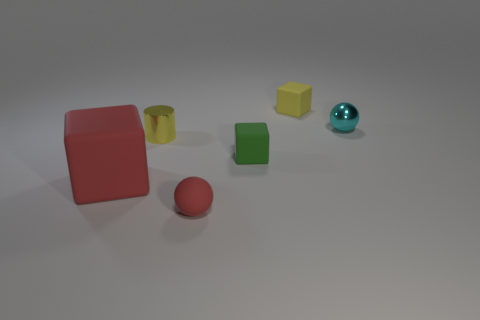What number of other things are the same color as the tiny shiny cylinder?
Provide a succinct answer. 1. How many small metallic objects are on the right side of the rubber thing behind the shiny object in front of the small cyan object?
Provide a short and direct response. 1. The cube that is in front of the small yellow metal object and behind the big cube is made of what material?
Keep it short and to the point. Rubber. Is the tiny red sphere made of the same material as the ball that is behind the big red cube?
Provide a short and direct response. No. Are there more large blocks behind the metallic cylinder than tiny green matte blocks that are in front of the red rubber block?
Give a very brief answer. No. What is the shape of the tiny red thing?
Your answer should be compact. Sphere. Do the sphere to the left of the cyan metallic ball and the tiny cube that is in front of the cyan metallic thing have the same material?
Your answer should be compact. Yes. What shape is the yellow object that is to the left of the tiny yellow matte cube?
Your answer should be very brief. Cylinder. The red object that is the same shape as the green rubber object is what size?
Provide a succinct answer. Large. Is the metal sphere the same color as the tiny metallic cylinder?
Keep it short and to the point. No. 